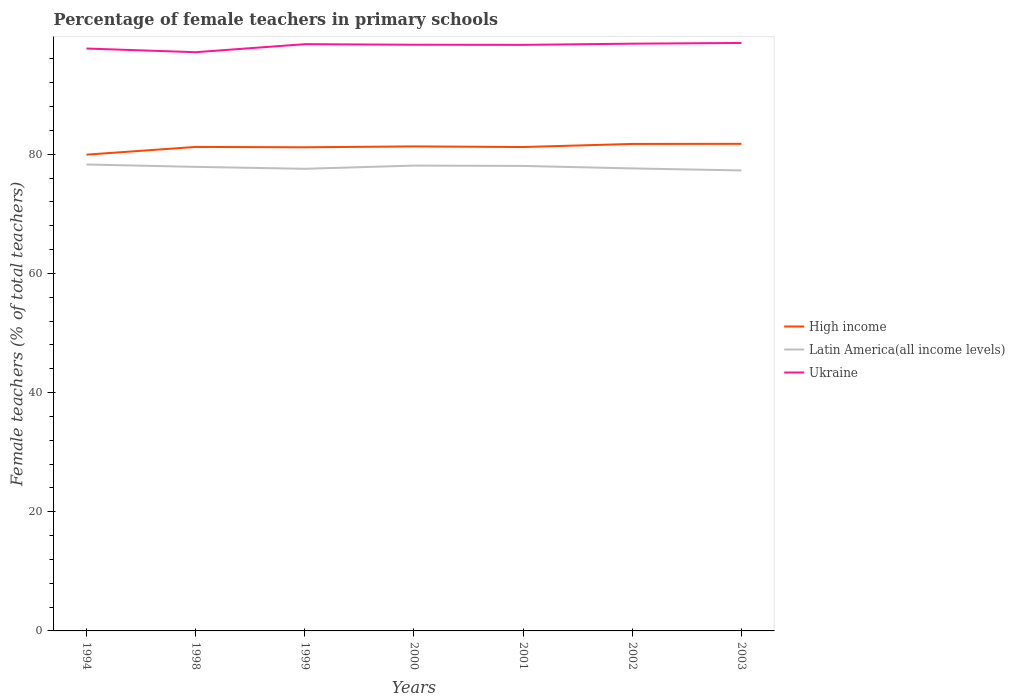How many different coloured lines are there?
Make the answer very short. 3. Does the line corresponding to Latin America(all income levels) intersect with the line corresponding to Ukraine?
Keep it short and to the point. No. Is the number of lines equal to the number of legend labels?
Offer a very short reply. Yes. Across all years, what is the maximum percentage of female teachers in High income?
Provide a short and direct response. 79.94. What is the total percentage of female teachers in High income in the graph?
Make the answer very short. -0.42. What is the difference between the highest and the second highest percentage of female teachers in Latin America(all income levels)?
Your answer should be compact. 1. What is the difference between the highest and the lowest percentage of female teachers in Latin America(all income levels)?
Keep it short and to the point. 4. How many lines are there?
Provide a short and direct response. 3. What is the difference between two consecutive major ticks on the Y-axis?
Provide a short and direct response. 20. Does the graph contain any zero values?
Give a very brief answer. No. Does the graph contain grids?
Provide a short and direct response. No. Where does the legend appear in the graph?
Give a very brief answer. Center right. What is the title of the graph?
Your answer should be compact. Percentage of female teachers in primary schools. What is the label or title of the X-axis?
Offer a very short reply. Years. What is the label or title of the Y-axis?
Your answer should be compact. Female teachers (% of total teachers). What is the Female teachers (% of total teachers) in High income in 1994?
Provide a succinct answer. 79.94. What is the Female teachers (% of total teachers) of Latin America(all income levels) in 1994?
Offer a very short reply. 78.29. What is the Female teachers (% of total teachers) in Ukraine in 1994?
Your answer should be very brief. 97.75. What is the Female teachers (% of total teachers) of High income in 1998?
Your answer should be compact. 81.24. What is the Female teachers (% of total teachers) of Latin America(all income levels) in 1998?
Make the answer very short. 77.89. What is the Female teachers (% of total teachers) in Ukraine in 1998?
Your response must be concise. 97.14. What is the Female teachers (% of total teachers) of High income in 1999?
Keep it short and to the point. 81.18. What is the Female teachers (% of total teachers) of Latin America(all income levels) in 1999?
Keep it short and to the point. 77.57. What is the Female teachers (% of total teachers) of Ukraine in 1999?
Offer a terse response. 98.48. What is the Female teachers (% of total teachers) in High income in 2000?
Offer a terse response. 81.32. What is the Female teachers (% of total teachers) in Latin America(all income levels) in 2000?
Provide a short and direct response. 78.11. What is the Female teachers (% of total teachers) of Ukraine in 2000?
Ensure brevity in your answer.  98.39. What is the Female teachers (% of total teachers) in High income in 2001?
Ensure brevity in your answer.  81.22. What is the Female teachers (% of total teachers) in Latin America(all income levels) in 2001?
Offer a very short reply. 78.05. What is the Female teachers (% of total teachers) in Ukraine in 2001?
Offer a very short reply. 98.37. What is the Female teachers (% of total teachers) of High income in 2002?
Provide a succinct answer. 81.74. What is the Female teachers (% of total teachers) of Latin America(all income levels) in 2002?
Your answer should be compact. 77.63. What is the Female teachers (% of total teachers) of Ukraine in 2002?
Ensure brevity in your answer.  98.57. What is the Female teachers (% of total teachers) in High income in 2003?
Your answer should be very brief. 81.76. What is the Female teachers (% of total teachers) in Latin America(all income levels) in 2003?
Make the answer very short. 77.29. What is the Female teachers (% of total teachers) in Ukraine in 2003?
Keep it short and to the point. 98.69. Across all years, what is the maximum Female teachers (% of total teachers) of High income?
Provide a short and direct response. 81.76. Across all years, what is the maximum Female teachers (% of total teachers) of Latin America(all income levels)?
Your answer should be very brief. 78.29. Across all years, what is the maximum Female teachers (% of total teachers) of Ukraine?
Make the answer very short. 98.69. Across all years, what is the minimum Female teachers (% of total teachers) in High income?
Make the answer very short. 79.94. Across all years, what is the minimum Female teachers (% of total teachers) of Latin America(all income levels)?
Offer a very short reply. 77.29. Across all years, what is the minimum Female teachers (% of total teachers) of Ukraine?
Provide a short and direct response. 97.14. What is the total Female teachers (% of total teachers) of High income in the graph?
Your response must be concise. 568.41. What is the total Female teachers (% of total teachers) of Latin America(all income levels) in the graph?
Offer a terse response. 544.83. What is the total Female teachers (% of total teachers) in Ukraine in the graph?
Your response must be concise. 687.4. What is the difference between the Female teachers (% of total teachers) in High income in 1994 and that in 1998?
Ensure brevity in your answer.  -1.3. What is the difference between the Female teachers (% of total teachers) in Latin America(all income levels) in 1994 and that in 1998?
Your answer should be compact. 0.4. What is the difference between the Female teachers (% of total teachers) in Ukraine in 1994 and that in 1998?
Your answer should be very brief. 0.62. What is the difference between the Female teachers (% of total teachers) of High income in 1994 and that in 1999?
Make the answer very short. -1.24. What is the difference between the Female teachers (% of total teachers) of Latin America(all income levels) in 1994 and that in 1999?
Your answer should be very brief. 0.73. What is the difference between the Female teachers (% of total teachers) in Ukraine in 1994 and that in 1999?
Ensure brevity in your answer.  -0.73. What is the difference between the Female teachers (% of total teachers) in High income in 1994 and that in 2000?
Offer a very short reply. -1.38. What is the difference between the Female teachers (% of total teachers) of Latin America(all income levels) in 1994 and that in 2000?
Keep it short and to the point. 0.18. What is the difference between the Female teachers (% of total teachers) in Ukraine in 1994 and that in 2000?
Provide a succinct answer. -0.64. What is the difference between the Female teachers (% of total teachers) of High income in 1994 and that in 2001?
Make the answer very short. -1.28. What is the difference between the Female teachers (% of total teachers) in Latin America(all income levels) in 1994 and that in 2001?
Keep it short and to the point. 0.24. What is the difference between the Female teachers (% of total teachers) in Ukraine in 1994 and that in 2001?
Provide a succinct answer. -0.61. What is the difference between the Female teachers (% of total teachers) in High income in 1994 and that in 2002?
Your response must be concise. -1.8. What is the difference between the Female teachers (% of total teachers) of Latin America(all income levels) in 1994 and that in 2002?
Your response must be concise. 0.66. What is the difference between the Female teachers (% of total teachers) in Ukraine in 1994 and that in 2002?
Make the answer very short. -0.81. What is the difference between the Female teachers (% of total teachers) of High income in 1994 and that in 2003?
Make the answer very short. -1.82. What is the difference between the Female teachers (% of total teachers) in Latin America(all income levels) in 1994 and that in 2003?
Give a very brief answer. 1. What is the difference between the Female teachers (% of total teachers) of Ukraine in 1994 and that in 2003?
Your response must be concise. -0.94. What is the difference between the Female teachers (% of total teachers) of High income in 1998 and that in 1999?
Provide a succinct answer. 0.06. What is the difference between the Female teachers (% of total teachers) in Latin America(all income levels) in 1998 and that in 1999?
Give a very brief answer. 0.33. What is the difference between the Female teachers (% of total teachers) in Ukraine in 1998 and that in 1999?
Provide a short and direct response. -1.35. What is the difference between the Female teachers (% of total teachers) in High income in 1998 and that in 2000?
Keep it short and to the point. -0.09. What is the difference between the Female teachers (% of total teachers) in Latin America(all income levels) in 1998 and that in 2000?
Make the answer very short. -0.21. What is the difference between the Female teachers (% of total teachers) of Ukraine in 1998 and that in 2000?
Your answer should be very brief. -1.25. What is the difference between the Female teachers (% of total teachers) in High income in 1998 and that in 2001?
Your answer should be very brief. 0.02. What is the difference between the Female teachers (% of total teachers) in Latin America(all income levels) in 1998 and that in 2001?
Provide a succinct answer. -0.16. What is the difference between the Female teachers (% of total teachers) of Ukraine in 1998 and that in 2001?
Offer a very short reply. -1.23. What is the difference between the Female teachers (% of total teachers) in High income in 1998 and that in 2002?
Your answer should be very brief. -0.5. What is the difference between the Female teachers (% of total teachers) of Latin America(all income levels) in 1998 and that in 2002?
Ensure brevity in your answer.  0.26. What is the difference between the Female teachers (% of total teachers) of Ukraine in 1998 and that in 2002?
Make the answer very short. -1.43. What is the difference between the Female teachers (% of total teachers) of High income in 1998 and that in 2003?
Give a very brief answer. -0.52. What is the difference between the Female teachers (% of total teachers) in Latin America(all income levels) in 1998 and that in 2003?
Keep it short and to the point. 0.6. What is the difference between the Female teachers (% of total teachers) of Ukraine in 1998 and that in 2003?
Offer a terse response. -1.55. What is the difference between the Female teachers (% of total teachers) of High income in 1999 and that in 2000?
Ensure brevity in your answer.  -0.14. What is the difference between the Female teachers (% of total teachers) of Latin America(all income levels) in 1999 and that in 2000?
Your response must be concise. -0.54. What is the difference between the Female teachers (% of total teachers) in Ukraine in 1999 and that in 2000?
Ensure brevity in your answer.  0.09. What is the difference between the Female teachers (% of total teachers) in High income in 1999 and that in 2001?
Provide a succinct answer. -0.04. What is the difference between the Female teachers (% of total teachers) of Latin America(all income levels) in 1999 and that in 2001?
Your answer should be compact. -0.48. What is the difference between the Female teachers (% of total teachers) in Ukraine in 1999 and that in 2001?
Your answer should be compact. 0.11. What is the difference between the Female teachers (% of total teachers) in High income in 1999 and that in 2002?
Give a very brief answer. -0.56. What is the difference between the Female teachers (% of total teachers) in Latin America(all income levels) in 1999 and that in 2002?
Offer a very short reply. -0.06. What is the difference between the Female teachers (% of total teachers) in Ukraine in 1999 and that in 2002?
Give a very brief answer. -0.08. What is the difference between the Female teachers (% of total teachers) of High income in 1999 and that in 2003?
Provide a succinct answer. -0.58. What is the difference between the Female teachers (% of total teachers) in Latin America(all income levels) in 1999 and that in 2003?
Ensure brevity in your answer.  0.27. What is the difference between the Female teachers (% of total teachers) of Ukraine in 1999 and that in 2003?
Give a very brief answer. -0.21. What is the difference between the Female teachers (% of total teachers) in High income in 2000 and that in 2001?
Keep it short and to the point. 0.1. What is the difference between the Female teachers (% of total teachers) in Latin America(all income levels) in 2000 and that in 2001?
Your answer should be compact. 0.06. What is the difference between the Female teachers (% of total teachers) of Ukraine in 2000 and that in 2001?
Your answer should be very brief. 0.02. What is the difference between the Female teachers (% of total teachers) in High income in 2000 and that in 2002?
Ensure brevity in your answer.  -0.42. What is the difference between the Female teachers (% of total teachers) in Latin America(all income levels) in 2000 and that in 2002?
Offer a terse response. 0.48. What is the difference between the Female teachers (% of total teachers) in Ukraine in 2000 and that in 2002?
Your response must be concise. -0.18. What is the difference between the Female teachers (% of total teachers) in High income in 2000 and that in 2003?
Offer a very short reply. -0.44. What is the difference between the Female teachers (% of total teachers) of Latin America(all income levels) in 2000 and that in 2003?
Offer a terse response. 0.82. What is the difference between the Female teachers (% of total teachers) of Ukraine in 2000 and that in 2003?
Your answer should be compact. -0.3. What is the difference between the Female teachers (% of total teachers) of High income in 2001 and that in 2002?
Provide a short and direct response. -0.52. What is the difference between the Female teachers (% of total teachers) in Latin America(all income levels) in 2001 and that in 2002?
Offer a terse response. 0.42. What is the difference between the Female teachers (% of total teachers) in Ukraine in 2001 and that in 2002?
Give a very brief answer. -0.2. What is the difference between the Female teachers (% of total teachers) of High income in 2001 and that in 2003?
Ensure brevity in your answer.  -0.54. What is the difference between the Female teachers (% of total teachers) of Latin America(all income levels) in 2001 and that in 2003?
Ensure brevity in your answer.  0.76. What is the difference between the Female teachers (% of total teachers) of Ukraine in 2001 and that in 2003?
Provide a succinct answer. -0.32. What is the difference between the Female teachers (% of total teachers) in High income in 2002 and that in 2003?
Provide a short and direct response. -0.02. What is the difference between the Female teachers (% of total teachers) in Latin America(all income levels) in 2002 and that in 2003?
Offer a terse response. 0.34. What is the difference between the Female teachers (% of total teachers) of Ukraine in 2002 and that in 2003?
Your answer should be very brief. -0.12. What is the difference between the Female teachers (% of total teachers) of High income in 1994 and the Female teachers (% of total teachers) of Latin America(all income levels) in 1998?
Your answer should be very brief. 2.05. What is the difference between the Female teachers (% of total teachers) of High income in 1994 and the Female teachers (% of total teachers) of Ukraine in 1998?
Give a very brief answer. -17.2. What is the difference between the Female teachers (% of total teachers) of Latin America(all income levels) in 1994 and the Female teachers (% of total teachers) of Ukraine in 1998?
Your answer should be compact. -18.85. What is the difference between the Female teachers (% of total teachers) in High income in 1994 and the Female teachers (% of total teachers) in Latin America(all income levels) in 1999?
Make the answer very short. 2.38. What is the difference between the Female teachers (% of total teachers) of High income in 1994 and the Female teachers (% of total teachers) of Ukraine in 1999?
Give a very brief answer. -18.54. What is the difference between the Female teachers (% of total teachers) in Latin America(all income levels) in 1994 and the Female teachers (% of total teachers) in Ukraine in 1999?
Ensure brevity in your answer.  -20.19. What is the difference between the Female teachers (% of total teachers) of High income in 1994 and the Female teachers (% of total teachers) of Latin America(all income levels) in 2000?
Your answer should be compact. 1.83. What is the difference between the Female teachers (% of total teachers) of High income in 1994 and the Female teachers (% of total teachers) of Ukraine in 2000?
Ensure brevity in your answer.  -18.45. What is the difference between the Female teachers (% of total teachers) of Latin America(all income levels) in 1994 and the Female teachers (% of total teachers) of Ukraine in 2000?
Offer a terse response. -20.1. What is the difference between the Female teachers (% of total teachers) of High income in 1994 and the Female teachers (% of total teachers) of Latin America(all income levels) in 2001?
Your answer should be very brief. 1.89. What is the difference between the Female teachers (% of total teachers) of High income in 1994 and the Female teachers (% of total teachers) of Ukraine in 2001?
Keep it short and to the point. -18.43. What is the difference between the Female teachers (% of total teachers) in Latin America(all income levels) in 1994 and the Female teachers (% of total teachers) in Ukraine in 2001?
Keep it short and to the point. -20.08. What is the difference between the Female teachers (% of total teachers) of High income in 1994 and the Female teachers (% of total teachers) of Latin America(all income levels) in 2002?
Give a very brief answer. 2.31. What is the difference between the Female teachers (% of total teachers) of High income in 1994 and the Female teachers (% of total teachers) of Ukraine in 2002?
Your answer should be compact. -18.63. What is the difference between the Female teachers (% of total teachers) in Latin America(all income levels) in 1994 and the Female teachers (% of total teachers) in Ukraine in 2002?
Ensure brevity in your answer.  -20.28. What is the difference between the Female teachers (% of total teachers) of High income in 1994 and the Female teachers (% of total teachers) of Latin America(all income levels) in 2003?
Offer a very short reply. 2.65. What is the difference between the Female teachers (% of total teachers) in High income in 1994 and the Female teachers (% of total teachers) in Ukraine in 2003?
Ensure brevity in your answer.  -18.75. What is the difference between the Female teachers (% of total teachers) in Latin America(all income levels) in 1994 and the Female teachers (% of total teachers) in Ukraine in 2003?
Offer a terse response. -20.4. What is the difference between the Female teachers (% of total teachers) in High income in 1998 and the Female teachers (% of total teachers) in Latin America(all income levels) in 1999?
Give a very brief answer. 3.67. What is the difference between the Female teachers (% of total teachers) in High income in 1998 and the Female teachers (% of total teachers) in Ukraine in 1999?
Your response must be concise. -17.25. What is the difference between the Female teachers (% of total teachers) of Latin America(all income levels) in 1998 and the Female teachers (% of total teachers) of Ukraine in 1999?
Offer a terse response. -20.59. What is the difference between the Female teachers (% of total teachers) in High income in 1998 and the Female teachers (% of total teachers) in Latin America(all income levels) in 2000?
Your answer should be compact. 3.13. What is the difference between the Female teachers (% of total teachers) in High income in 1998 and the Female teachers (% of total teachers) in Ukraine in 2000?
Ensure brevity in your answer.  -17.15. What is the difference between the Female teachers (% of total teachers) in Latin America(all income levels) in 1998 and the Female teachers (% of total teachers) in Ukraine in 2000?
Offer a very short reply. -20.5. What is the difference between the Female teachers (% of total teachers) in High income in 1998 and the Female teachers (% of total teachers) in Latin America(all income levels) in 2001?
Your answer should be very brief. 3.19. What is the difference between the Female teachers (% of total teachers) of High income in 1998 and the Female teachers (% of total teachers) of Ukraine in 2001?
Your answer should be very brief. -17.13. What is the difference between the Female teachers (% of total teachers) of Latin America(all income levels) in 1998 and the Female teachers (% of total teachers) of Ukraine in 2001?
Offer a terse response. -20.48. What is the difference between the Female teachers (% of total teachers) of High income in 1998 and the Female teachers (% of total teachers) of Latin America(all income levels) in 2002?
Your response must be concise. 3.61. What is the difference between the Female teachers (% of total teachers) of High income in 1998 and the Female teachers (% of total teachers) of Ukraine in 2002?
Your answer should be very brief. -17.33. What is the difference between the Female teachers (% of total teachers) in Latin America(all income levels) in 1998 and the Female teachers (% of total teachers) in Ukraine in 2002?
Your response must be concise. -20.68. What is the difference between the Female teachers (% of total teachers) in High income in 1998 and the Female teachers (% of total teachers) in Latin America(all income levels) in 2003?
Your answer should be compact. 3.95. What is the difference between the Female teachers (% of total teachers) of High income in 1998 and the Female teachers (% of total teachers) of Ukraine in 2003?
Your answer should be compact. -17.45. What is the difference between the Female teachers (% of total teachers) of Latin America(all income levels) in 1998 and the Female teachers (% of total teachers) of Ukraine in 2003?
Offer a very short reply. -20.8. What is the difference between the Female teachers (% of total teachers) of High income in 1999 and the Female teachers (% of total teachers) of Latin America(all income levels) in 2000?
Keep it short and to the point. 3.07. What is the difference between the Female teachers (% of total teachers) of High income in 1999 and the Female teachers (% of total teachers) of Ukraine in 2000?
Offer a terse response. -17.21. What is the difference between the Female teachers (% of total teachers) of Latin America(all income levels) in 1999 and the Female teachers (% of total teachers) of Ukraine in 2000?
Offer a terse response. -20.82. What is the difference between the Female teachers (% of total teachers) in High income in 1999 and the Female teachers (% of total teachers) in Latin America(all income levels) in 2001?
Your answer should be very brief. 3.13. What is the difference between the Female teachers (% of total teachers) of High income in 1999 and the Female teachers (% of total teachers) of Ukraine in 2001?
Keep it short and to the point. -17.19. What is the difference between the Female teachers (% of total teachers) in Latin America(all income levels) in 1999 and the Female teachers (% of total teachers) in Ukraine in 2001?
Give a very brief answer. -20.8. What is the difference between the Female teachers (% of total teachers) in High income in 1999 and the Female teachers (% of total teachers) in Latin America(all income levels) in 2002?
Give a very brief answer. 3.55. What is the difference between the Female teachers (% of total teachers) in High income in 1999 and the Female teachers (% of total teachers) in Ukraine in 2002?
Ensure brevity in your answer.  -17.39. What is the difference between the Female teachers (% of total teachers) of Latin America(all income levels) in 1999 and the Female teachers (% of total teachers) of Ukraine in 2002?
Offer a very short reply. -21. What is the difference between the Female teachers (% of total teachers) of High income in 1999 and the Female teachers (% of total teachers) of Latin America(all income levels) in 2003?
Provide a succinct answer. 3.89. What is the difference between the Female teachers (% of total teachers) of High income in 1999 and the Female teachers (% of total teachers) of Ukraine in 2003?
Give a very brief answer. -17.51. What is the difference between the Female teachers (% of total teachers) of Latin America(all income levels) in 1999 and the Female teachers (% of total teachers) of Ukraine in 2003?
Ensure brevity in your answer.  -21.12. What is the difference between the Female teachers (% of total teachers) in High income in 2000 and the Female teachers (% of total teachers) in Latin America(all income levels) in 2001?
Offer a very short reply. 3.27. What is the difference between the Female teachers (% of total teachers) of High income in 2000 and the Female teachers (% of total teachers) of Ukraine in 2001?
Keep it short and to the point. -17.05. What is the difference between the Female teachers (% of total teachers) in Latin America(all income levels) in 2000 and the Female teachers (% of total teachers) in Ukraine in 2001?
Provide a succinct answer. -20.26. What is the difference between the Female teachers (% of total teachers) of High income in 2000 and the Female teachers (% of total teachers) of Latin America(all income levels) in 2002?
Ensure brevity in your answer.  3.7. What is the difference between the Female teachers (% of total teachers) of High income in 2000 and the Female teachers (% of total teachers) of Ukraine in 2002?
Your response must be concise. -17.24. What is the difference between the Female teachers (% of total teachers) of Latin America(all income levels) in 2000 and the Female teachers (% of total teachers) of Ukraine in 2002?
Make the answer very short. -20.46. What is the difference between the Female teachers (% of total teachers) of High income in 2000 and the Female teachers (% of total teachers) of Latin America(all income levels) in 2003?
Offer a very short reply. 4.03. What is the difference between the Female teachers (% of total teachers) of High income in 2000 and the Female teachers (% of total teachers) of Ukraine in 2003?
Offer a very short reply. -17.37. What is the difference between the Female teachers (% of total teachers) of Latin America(all income levels) in 2000 and the Female teachers (% of total teachers) of Ukraine in 2003?
Provide a succinct answer. -20.58. What is the difference between the Female teachers (% of total teachers) in High income in 2001 and the Female teachers (% of total teachers) in Latin America(all income levels) in 2002?
Your response must be concise. 3.59. What is the difference between the Female teachers (% of total teachers) in High income in 2001 and the Female teachers (% of total teachers) in Ukraine in 2002?
Make the answer very short. -17.35. What is the difference between the Female teachers (% of total teachers) in Latin America(all income levels) in 2001 and the Female teachers (% of total teachers) in Ukraine in 2002?
Your answer should be compact. -20.52. What is the difference between the Female teachers (% of total teachers) of High income in 2001 and the Female teachers (% of total teachers) of Latin America(all income levels) in 2003?
Offer a very short reply. 3.93. What is the difference between the Female teachers (% of total teachers) of High income in 2001 and the Female teachers (% of total teachers) of Ukraine in 2003?
Make the answer very short. -17.47. What is the difference between the Female teachers (% of total teachers) of Latin America(all income levels) in 2001 and the Female teachers (% of total teachers) of Ukraine in 2003?
Your answer should be very brief. -20.64. What is the difference between the Female teachers (% of total teachers) in High income in 2002 and the Female teachers (% of total teachers) in Latin America(all income levels) in 2003?
Give a very brief answer. 4.45. What is the difference between the Female teachers (% of total teachers) of High income in 2002 and the Female teachers (% of total teachers) of Ukraine in 2003?
Ensure brevity in your answer.  -16.95. What is the difference between the Female teachers (% of total teachers) of Latin America(all income levels) in 2002 and the Female teachers (% of total teachers) of Ukraine in 2003?
Give a very brief answer. -21.06. What is the average Female teachers (% of total teachers) of High income per year?
Offer a terse response. 81.2. What is the average Female teachers (% of total teachers) of Latin America(all income levels) per year?
Ensure brevity in your answer.  77.83. What is the average Female teachers (% of total teachers) of Ukraine per year?
Provide a succinct answer. 98.2. In the year 1994, what is the difference between the Female teachers (% of total teachers) of High income and Female teachers (% of total teachers) of Latin America(all income levels)?
Your answer should be very brief. 1.65. In the year 1994, what is the difference between the Female teachers (% of total teachers) in High income and Female teachers (% of total teachers) in Ukraine?
Provide a succinct answer. -17.81. In the year 1994, what is the difference between the Female teachers (% of total teachers) in Latin America(all income levels) and Female teachers (% of total teachers) in Ukraine?
Make the answer very short. -19.46. In the year 1998, what is the difference between the Female teachers (% of total teachers) of High income and Female teachers (% of total teachers) of Latin America(all income levels)?
Keep it short and to the point. 3.35. In the year 1998, what is the difference between the Female teachers (% of total teachers) in High income and Female teachers (% of total teachers) in Ukraine?
Your answer should be very brief. -15.9. In the year 1998, what is the difference between the Female teachers (% of total teachers) of Latin America(all income levels) and Female teachers (% of total teachers) of Ukraine?
Give a very brief answer. -19.25. In the year 1999, what is the difference between the Female teachers (% of total teachers) in High income and Female teachers (% of total teachers) in Latin America(all income levels)?
Your response must be concise. 3.61. In the year 1999, what is the difference between the Female teachers (% of total teachers) in High income and Female teachers (% of total teachers) in Ukraine?
Offer a terse response. -17.3. In the year 1999, what is the difference between the Female teachers (% of total teachers) in Latin America(all income levels) and Female teachers (% of total teachers) in Ukraine?
Give a very brief answer. -20.92. In the year 2000, what is the difference between the Female teachers (% of total teachers) of High income and Female teachers (% of total teachers) of Latin America(all income levels)?
Give a very brief answer. 3.22. In the year 2000, what is the difference between the Female teachers (% of total teachers) of High income and Female teachers (% of total teachers) of Ukraine?
Keep it short and to the point. -17.07. In the year 2000, what is the difference between the Female teachers (% of total teachers) of Latin America(all income levels) and Female teachers (% of total teachers) of Ukraine?
Your response must be concise. -20.28. In the year 2001, what is the difference between the Female teachers (% of total teachers) of High income and Female teachers (% of total teachers) of Latin America(all income levels)?
Your answer should be compact. 3.17. In the year 2001, what is the difference between the Female teachers (% of total teachers) in High income and Female teachers (% of total teachers) in Ukraine?
Provide a succinct answer. -17.15. In the year 2001, what is the difference between the Female teachers (% of total teachers) of Latin America(all income levels) and Female teachers (% of total teachers) of Ukraine?
Offer a very short reply. -20.32. In the year 2002, what is the difference between the Female teachers (% of total teachers) in High income and Female teachers (% of total teachers) in Latin America(all income levels)?
Make the answer very short. 4.11. In the year 2002, what is the difference between the Female teachers (% of total teachers) of High income and Female teachers (% of total teachers) of Ukraine?
Provide a succinct answer. -16.83. In the year 2002, what is the difference between the Female teachers (% of total teachers) in Latin America(all income levels) and Female teachers (% of total teachers) in Ukraine?
Offer a terse response. -20.94. In the year 2003, what is the difference between the Female teachers (% of total teachers) of High income and Female teachers (% of total teachers) of Latin America(all income levels)?
Offer a terse response. 4.47. In the year 2003, what is the difference between the Female teachers (% of total teachers) in High income and Female teachers (% of total teachers) in Ukraine?
Offer a very short reply. -16.93. In the year 2003, what is the difference between the Female teachers (% of total teachers) of Latin America(all income levels) and Female teachers (% of total teachers) of Ukraine?
Offer a terse response. -21.4. What is the ratio of the Female teachers (% of total teachers) of Latin America(all income levels) in 1994 to that in 1998?
Offer a very short reply. 1.01. What is the ratio of the Female teachers (% of total teachers) of Ukraine in 1994 to that in 1998?
Ensure brevity in your answer.  1.01. What is the ratio of the Female teachers (% of total teachers) of High income in 1994 to that in 1999?
Offer a very short reply. 0.98. What is the ratio of the Female teachers (% of total teachers) in Latin America(all income levels) in 1994 to that in 1999?
Offer a very short reply. 1.01. What is the ratio of the Female teachers (% of total teachers) in Ukraine in 1994 to that in 1999?
Provide a succinct answer. 0.99. What is the ratio of the Female teachers (% of total teachers) of High income in 1994 to that in 2000?
Ensure brevity in your answer.  0.98. What is the ratio of the Female teachers (% of total teachers) in Ukraine in 1994 to that in 2000?
Ensure brevity in your answer.  0.99. What is the ratio of the Female teachers (% of total teachers) of High income in 1994 to that in 2001?
Your response must be concise. 0.98. What is the ratio of the Female teachers (% of total teachers) in Latin America(all income levels) in 1994 to that in 2001?
Make the answer very short. 1. What is the ratio of the Female teachers (% of total teachers) in High income in 1994 to that in 2002?
Make the answer very short. 0.98. What is the ratio of the Female teachers (% of total teachers) of Latin America(all income levels) in 1994 to that in 2002?
Make the answer very short. 1.01. What is the ratio of the Female teachers (% of total teachers) of Ukraine in 1994 to that in 2002?
Make the answer very short. 0.99. What is the ratio of the Female teachers (% of total teachers) of High income in 1994 to that in 2003?
Ensure brevity in your answer.  0.98. What is the ratio of the Female teachers (% of total teachers) of Latin America(all income levels) in 1994 to that in 2003?
Offer a very short reply. 1.01. What is the ratio of the Female teachers (% of total teachers) of Ukraine in 1994 to that in 2003?
Keep it short and to the point. 0.99. What is the ratio of the Female teachers (% of total teachers) of Latin America(all income levels) in 1998 to that in 1999?
Ensure brevity in your answer.  1. What is the ratio of the Female teachers (% of total teachers) of Ukraine in 1998 to that in 1999?
Keep it short and to the point. 0.99. What is the ratio of the Female teachers (% of total teachers) in Ukraine in 1998 to that in 2000?
Your answer should be compact. 0.99. What is the ratio of the Female teachers (% of total teachers) of Ukraine in 1998 to that in 2001?
Give a very brief answer. 0.99. What is the ratio of the Female teachers (% of total teachers) in High income in 1998 to that in 2002?
Your answer should be very brief. 0.99. What is the ratio of the Female teachers (% of total teachers) in Latin America(all income levels) in 1998 to that in 2002?
Your response must be concise. 1. What is the ratio of the Female teachers (% of total teachers) of Ukraine in 1998 to that in 2002?
Provide a short and direct response. 0.99. What is the ratio of the Female teachers (% of total teachers) of Latin America(all income levels) in 1998 to that in 2003?
Offer a terse response. 1.01. What is the ratio of the Female teachers (% of total teachers) in Ukraine in 1998 to that in 2003?
Your answer should be very brief. 0.98. What is the ratio of the Female teachers (% of total teachers) in High income in 1999 to that in 2000?
Your answer should be compact. 1. What is the ratio of the Female teachers (% of total teachers) of Latin America(all income levels) in 1999 to that in 2000?
Give a very brief answer. 0.99. What is the ratio of the Female teachers (% of total teachers) in High income in 1999 to that in 2001?
Provide a succinct answer. 1. What is the ratio of the Female teachers (% of total teachers) in Ukraine in 1999 to that in 2001?
Your answer should be compact. 1. What is the ratio of the Female teachers (% of total teachers) of High income in 1999 to that in 2002?
Your answer should be very brief. 0.99. What is the ratio of the Female teachers (% of total teachers) of Latin America(all income levels) in 1999 to that in 2003?
Give a very brief answer. 1. What is the ratio of the Female teachers (% of total teachers) of Ukraine in 1999 to that in 2003?
Ensure brevity in your answer.  1. What is the ratio of the Female teachers (% of total teachers) in High income in 2000 to that in 2001?
Ensure brevity in your answer.  1. What is the ratio of the Female teachers (% of total teachers) in Ukraine in 2000 to that in 2001?
Your response must be concise. 1. What is the ratio of the Female teachers (% of total teachers) in Latin America(all income levels) in 2000 to that in 2002?
Provide a succinct answer. 1.01. What is the ratio of the Female teachers (% of total teachers) of Latin America(all income levels) in 2000 to that in 2003?
Offer a very short reply. 1.01. What is the ratio of the Female teachers (% of total teachers) of Ukraine in 2000 to that in 2003?
Ensure brevity in your answer.  1. What is the ratio of the Female teachers (% of total teachers) in Latin America(all income levels) in 2001 to that in 2002?
Provide a short and direct response. 1.01. What is the ratio of the Female teachers (% of total teachers) in High income in 2001 to that in 2003?
Offer a very short reply. 0.99. What is the ratio of the Female teachers (% of total teachers) of Latin America(all income levels) in 2001 to that in 2003?
Ensure brevity in your answer.  1.01. What is the ratio of the Female teachers (% of total teachers) in High income in 2002 to that in 2003?
Give a very brief answer. 1. What is the ratio of the Female teachers (% of total teachers) of Latin America(all income levels) in 2002 to that in 2003?
Your answer should be very brief. 1. What is the ratio of the Female teachers (% of total teachers) in Ukraine in 2002 to that in 2003?
Your answer should be compact. 1. What is the difference between the highest and the second highest Female teachers (% of total teachers) in High income?
Your answer should be very brief. 0.02. What is the difference between the highest and the second highest Female teachers (% of total teachers) in Latin America(all income levels)?
Offer a very short reply. 0.18. What is the difference between the highest and the second highest Female teachers (% of total teachers) of Ukraine?
Your response must be concise. 0.12. What is the difference between the highest and the lowest Female teachers (% of total teachers) in High income?
Your answer should be compact. 1.82. What is the difference between the highest and the lowest Female teachers (% of total teachers) of Ukraine?
Provide a short and direct response. 1.55. 